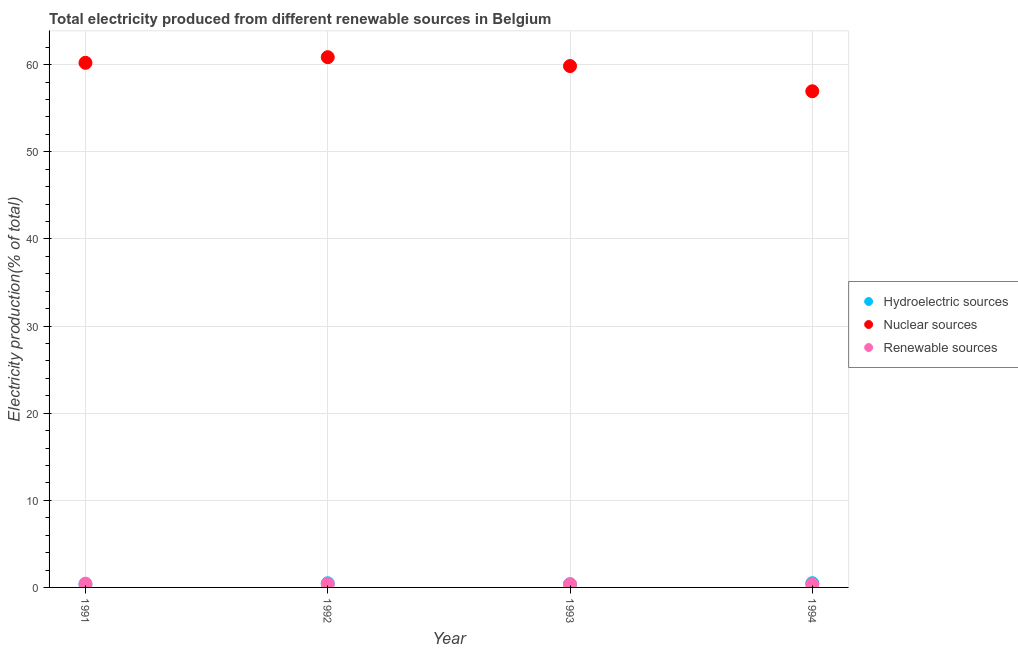Is the number of dotlines equal to the number of legend labels?
Make the answer very short. Yes. What is the percentage of electricity produced by nuclear sources in 1994?
Your answer should be compact. 56.94. Across all years, what is the maximum percentage of electricity produced by hydroelectric sources?
Provide a succinct answer. 0.48. Across all years, what is the minimum percentage of electricity produced by nuclear sources?
Offer a terse response. 56.94. In which year was the percentage of electricity produced by nuclear sources maximum?
Make the answer very short. 1992. In which year was the percentage of electricity produced by renewable sources minimum?
Your answer should be compact. 1994. What is the total percentage of electricity produced by nuclear sources in the graph?
Give a very brief answer. 237.85. What is the difference between the percentage of electricity produced by nuclear sources in 1991 and that in 1993?
Give a very brief answer. 0.37. What is the difference between the percentage of electricity produced by hydroelectric sources in 1992 and the percentage of electricity produced by renewable sources in 1991?
Your answer should be compact. 0.05. What is the average percentage of electricity produced by renewable sources per year?
Ensure brevity in your answer.  0.38. In the year 1992, what is the difference between the percentage of electricity produced by hydroelectric sources and percentage of electricity produced by renewable sources?
Give a very brief answer. 0.09. What is the ratio of the percentage of electricity produced by hydroelectric sources in 1991 to that in 1992?
Give a very brief answer. 0.67. What is the difference between the highest and the second highest percentage of electricity produced by nuclear sources?
Give a very brief answer. 0.64. What is the difference between the highest and the lowest percentage of electricity produced by hydroelectric sources?
Offer a terse response. 0.16. Is the percentage of electricity produced by nuclear sources strictly greater than the percentage of electricity produced by hydroelectric sources over the years?
Your response must be concise. Yes. Is the percentage of electricity produced by nuclear sources strictly less than the percentage of electricity produced by hydroelectric sources over the years?
Provide a succinct answer. No. Are the values on the major ticks of Y-axis written in scientific E-notation?
Make the answer very short. No. Does the graph contain any zero values?
Provide a succinct answer. No. Does the graph contain grids?
Provide a succinct answer. Yes. How are the legend labels stacked?
Offer a terse response. Vertical. What is the title of the graph?
Your answer should be very brief. Total electricity produced from different renewable sources in Belgium. Does "Negligence towards kids" appear as one of the legend labels in the graph?
Provide a succinct answer. No. What is the label or title of the Y-axis?
Your answer should be compact. Electricity production(% of total). What is the Electricity production(% of total) in Hydroelectric sources in 1991?
Give a very brief answer. 0.32. What is the Electricity production(% of total) of Nuclear sources in 1991?
Offer a terse response. 60.21. What is the Electricity production(% of total) in Renewable sources in 1991?
Provide a succinct answer. 0.43. What is the Electricity production(% of total) in Hydroelectric sources in 1992?
Offer a terse response. 0.48. What is the Electricity production(% of total) of Nuclear sources in 1992?
Provide a short and direct response. 60.85. What is the Electricity production(% of total) of Renewable sources in 1992?
Ensure brevity in your answer.  0.39. What is the Electricity production(% of total) in Hydroelectric sources in 1993?
Offer a terse response. 0.36. What is the Electricity production(% of total) in Nuclear sources in 1993?
Your answer should be very brief. 59.84. What is the Electricity production(% of total) of Renewable sources in 1993?
Ensure brevity in your answer.  0.36. What is the Electricity production(% of total) in Hydroelectric sources in 1994?
Offer a terse response. 0.48. What is the Electricity production(% of total) in Nuclear sources in 1994?
Keep it short and to the point. 56.94. What is the Electricity production(% of total) of Renewable sources in 1994?
Your answer should be compact. 0.36. Across all years, what is the maximum Electricity production(% of total) in Hydroelectric sources?
Your answer should be very brief. 0.48. Across all years, what is the maximum Electricity production(% of total) in Nuclear sources?
Your response must be concise. 60.85. Across all years, what is the maximum Electricity production(% of total) of Renewable sources?
Offer a very short reply. 0.43. Across all years, what is the minimum Electricity production(% of total) of Hydroelectric sources?
Your answer should be compact. 0.32. Across all years, what is the minimum Electricity production(% of total) of Nuclear sources?
Provide a short and direct response. 56.94. Across all years, what is the minimum Electricity production(% of total) of Renewable sources?
Make the answer very short. 0.36. What is the total Electricity production(% of total) in Hydroelectric sources in the graph?
Provide a short and direct response. 1.65. What is the total Electricity production(% of total) in Nuclear sources in the graph?
Your answer should be compact. 237.85. What is the total Electricity production(% of total) in Renewable sources in the graph?
Provide a succinct answer. 1.53. What is the difference between the Electricity production(% of total) of Hydroelectric sources in 1991 and that in 1992?
Make the answer very short. -0.16. What is the difference between the Electricity production(% of total) of Nuclear sources in 1991 and that in 1992?
Offer a terse response. -0.64. What is the difference between the Electricity production(% of total) in Renewable sources in 1991 and that in 1992?
Give a very brief answer. 0.04. What is the difference between the Electricity production(% of total) in Hydroelectric sources in 1991 and that in 1993?
Provide a succinct answer. -0.04. What is the difference between the Electricity production(% of total) of Nuclear sources in 1991 and that in 1993?
Your answer should be compact. 0.37. What is the difference between the Electricity production(% of total) of Renewable sources in 1991 and that in 1993?
Offer a terse response. 0.07. What is the difference between the Electricity production(% of total) in Hydroelectric sources in 1991 and that in 1994?
Keep it short and to the point. -0.16. What is the difference between the Electricity production(% of total) in Nuclear sources in 1991 and that in 1994?
Offer a very short reply. 3.27. What is the difference between the Electricity production(% of total) of Renewable sources in 1991 and that in 1994?
Offer a terse response. 0.08. What is the difference between the Electricity production(% of total) in Hydroelectric sources in 1992 and that in 1993?
Offer a terse response. 0.12. What is the difference between the Electricity production(% of total) in Nuclear sources in 1992 and that in 1993?
Your response must be concise. 1.02. What is the difference between the Electricity production(% of total) of Renewable sources in 1992 and that in 1993?
Offer a terse response. 0.03. What is the difference between the Electricity production(% of total) in Hydroelectric sources in 1992 and that in 1994?
Make the answer very short. -0.01. What is the difference between the Electricity production(% of total) in Nuclear sources in 1992 and that in 1994?
Make the answer very short. 3.91. What is the difference between the Electricity production(% of total) in Renewable sources in 1992 and that in 1994?
Offer a terse response. 0.03. What is the difference between the Electricity production(% of total) in Hydroelectric sources in 1993 and that in 1994?
Your answer should be very brief. -0.12. What is the difference between the Electricity production(% of total) in Nuclear sources in 1993 and that in 1994?
Offer a very short reply. 2.89. What is the difference between the Electricity production(% of total) of Renewable sources in 1993 and that in 1994?
Offer a very short reply. 0.01. What is the difference between the Electricity production(% of total) in Hydroelectric sources in 1991 and the Electricity production(% of total) in Nuclear sources in 1992?
Provide a short and direct response. -60.53. What is the difference between the Electricity production(% of total) in Hydroelectric sources in 1991 and the Electricity production(% of total) in Renewable sources in 1992?
Make the answer very short. -0.06. What is the difference between the Electricity production(% of total) of Nuclear sources in 1991 and the Electricity production(% of total) of Renewable sources in 1992?
Offer a terse response. 59.82. What is the difference between the Electricity production(% of total) in Hydroelectric sources in 1991 and the Electricity production(% of total) in Nuclear sources in 1993?
Make the answer very short. -59.52. What is the difference between the Electricity production(% of total) in Hydroelectric sources in 1991 and the Electricity production(% of total) in Renewable sources in 1993?
Make the answer very short. -0.04. What is the difference between the Electricity production(% of total) in Nuclear sources in 1991 and the Electricity production(% of total) in Renewable sources in 1993?
Make the answer very short. 59.85. What is the difference between the Electricity production(% of total) in Hydroelectric sources in 1991 and the Electricity production(% of total) in Nuclear sources in 1994?
Make the answer very short. -56.62. What is the difference between the Electricity production(% of total) of Hydroelectric sources in 1991 and the Electricity production(% of total) of Renewable sources in 1994?
Your response must be concise. -0.03. What is the difference between the Electricity production(% of total) in Nuclear sources in 1991 and the Electricity production(% of total) in Renewable sources in 1994?
Provide a short and direct response. 59.85. What is the difference between the Electricity production(% of total) in Hydroelectric sources in 1992 and the Electricity production(% of total) in Nuclear sources in 1993?
Make the answer very short. -59.36. What is the difference between the Electricity production(% of total) in Hydroelectric sources in 1992 and the Electricity production(% of total) in Renewable sources in 1993?
Offer a terse response. 0.12. What is the difference between the Electricity production(% of total) of Nuclear sources in 1992 and the Electricity production(% of total) of Renewable sources in 1993?
Your response must be concise. 60.49. What is the difference between the Electricity production(% of total) of Hydroelectric sources in 1992 and the Electricity production(% of total) of Nuclear sources in 1994?
Keep it short and to the point. -56.47. What is the difference between the Electricity production(% of total) of Hydroelectric sources in 1992 and the Electricity production(% of total) of Renewable sources in 1994?
Your answer should be very brief. 0.12. What is the difference between the Electricity production(% of total) in Nuclear sources in 1992 and the Electricity production(% of total) in Renewable sources in 1994?
Keep it short and to the point. 60.5. What is the difference between the Electricity production(% of total) of Hydroelectric sources in 1993 and the Electricity production(% of total) of Nuclear sources in 1994?
Keep it short and to the point. -56.58. What is the difference between the Electricity production(% of total) of Hydroelectric sources in 1993 and the Electricity production(% of total) of Renewable sources in 1994?
Your answer should be very brief. 0.01. What is the difference between the Electricity production(% of total) in Nuclear sources in 1993 and the Electricity production(% of total) in Renewable sources in 1994?
Give a very brief answer. 59.48. What is the average Electricity production(% of total) of Hydroelectric sources per year?
Your answer should be compact. 0.41. What is the average Electricity production(% of total) of Nuclear sources per year?
Give a very brief answer. 59.46. What is the average Electricity production(% of total) in Renewable sources per year?
Ensure brevity in your answer.  0.38. In the year 1991, what is the difference between the Electricity production(% of total) in Hydroelectric sources and Electricity production(% of total) in Nuclear sources?
Keep it short and to the point. -59.89. In the year 1991, what is the difference between the Electricity production(% of total) of Hydroelectric sources and Electricity production(% of total) of Renewable sources?
Keep it short and to the point. -0.11. In the year 1991, what is the difference between the Electricity production(% of total) of Nuclear sources and Electricity production(% of total) of Renewable sources?
Give a very brief answer. 59.78. In the year 1992, what is the difference between the Electricity production(% of total) of Hydroelectric sources and Electricity production(% of total) of Nuclear sources?
Give a very brief answer. -60.38. In the year 1992, what is the difference between the Electricity production(% of total) in Hydroelectric sources and Electricity production(% of total) in Renewable sources?
Make the answer very short. 0.09. In the year 1992, what is the difference between the Electricity production(% of total) in Nuclear sources and Electricity production(% of total) in Renewable sources?
Provide a succinct answer. 60.47. In the year 1993, what is the difference between the Electricity production(% of total) of Hydroelectric sources and Electricity production(% of total) of Nuclear sources?
Your answer should be very brief. -59.48. In the year 1993, what is the difference between the Electricity production(% of total) in Hydroelectric sources and Electricity production(% of total) in Renewable sources?
Provide a succinct answer. 0. In the year 1993, what is the difference between the Electricity production(% of total) of Nuclear sources and Electricity production(% of total) of Renewable sources?
Offer a terse response. 59.48. In the year 1994, what is the difference between the Electricity production(% of total) in Hydroelectric sources and Electricity production(% of total) in Nuclear sources?
Give a very brief answer. -56.46. In the year 1994, what is the difference between the Electricity production(% of total) of Hydroelectric sources and Electricity production(% of total) of Renewable sources?
Give a very brief answer. 0.13. In the year 1994, what is the difference between the Electricity production(% of total) in Nuclear sources and Electricity production(% of total) in Renewable sources?
Keep it short and to the point. 56.59. What is the ratio of the Electricity production(% of total) in Hydroelectric sources in 1991 to that in 1992?
Keep it short and to the point. 0.67. What is the ratio of the Electricity production(% of total) of Nuclear sources in 1991 to that in 1992?
Make the answer very short. 0.99. What is the ratio of the Electricity production(% of total) of Renewable sources in 1991 to that in 1992?
Provide a succinct answer. 1.12. What is the ratio of the Electricity production(% of total) of Hydroelectric sources in 1991 to that in 1993?
Provide a short and direct response. 0.89. What is the ratio of the Electricity production(% of total) in Renewable sources in 1991 to that in 1993?
Your answer should be very brief. 1.19. What is the ratio of the Electricity production(% of total) of Hydroelectric sources in 1991 to that in 1994?
Offer a very short reply. 0.66. What is the ratio of the Electricity production(% of total) in Nuclear sources in 1991 to that in 1994?
Offer a terse response. 1.06. What is the ratio of the Electricity production(% of total) of Renewable sources in 1991 to that in 1994?
Ensure brevity in your answer.  1.21. What is the ratio of the Electricity production(% of total) in Hydroelectric sources in 1992 to that in 1993?
Make the answer very short. 1.32. What is the ratio of the Electricity production(% of total) in Renewable sources in 1992 to that in 1993?
Provide a succinct answer. 1.07. What is the ratio of the Electricity production(% of total) of Hydroelectric sources in 1992 to that in 1994?
Provide a succinct answer. 0.98. What is the ratio of the Electricity production(% of total) in Nuclear sources in 1992 to that in 1994?
Give a very brief answer. 1.07. What is the ratio of the Electricity production(% of total) of Renewable sources in 1992 to that in 1994?
Your answer should be compact. 1.09. What is the ratio of the Electricity production(% of total) in Hydroelectric sources in 1993 to that in 1994?
Keep it short and to the point. 0.75. What is the ratio of the Electricity production(% of total) of Nuclear sources in 1993 to that in 1994?
Provide a short and direct response. 1.05. What is the ratio of the Electricity production(% of total) of Renewable sources in 1993 to that in 1994?
Your response must be concise. 1.01. What is the difference between the highest and the second highest Electricity production(% of total) in Hydroelectric sources?
Offer a terse response. 0.01. What is the difference between the highest and the second highest Electricity production(% of total) of Nuclear sources?
Provide a short and direct response. 0.64. What is the difference between the highest and the second highest Electricity production(% of total) of Renewable sources?
Offer a very short reply. 0.04. What is the difference between the highest and the lowest Electricity production(% of total) in Hydroelectric sources?
Provide a succinct answer. 0.16. What is the difference between the highest and the lowest Electricity production(% of total) of Nuclear sources?
Your answer should be very brief. 3.91. What is the difference between the highest and the lowest Electricity production(% of total) of Renewable sources?
Give a very brief answer. 0.08. 